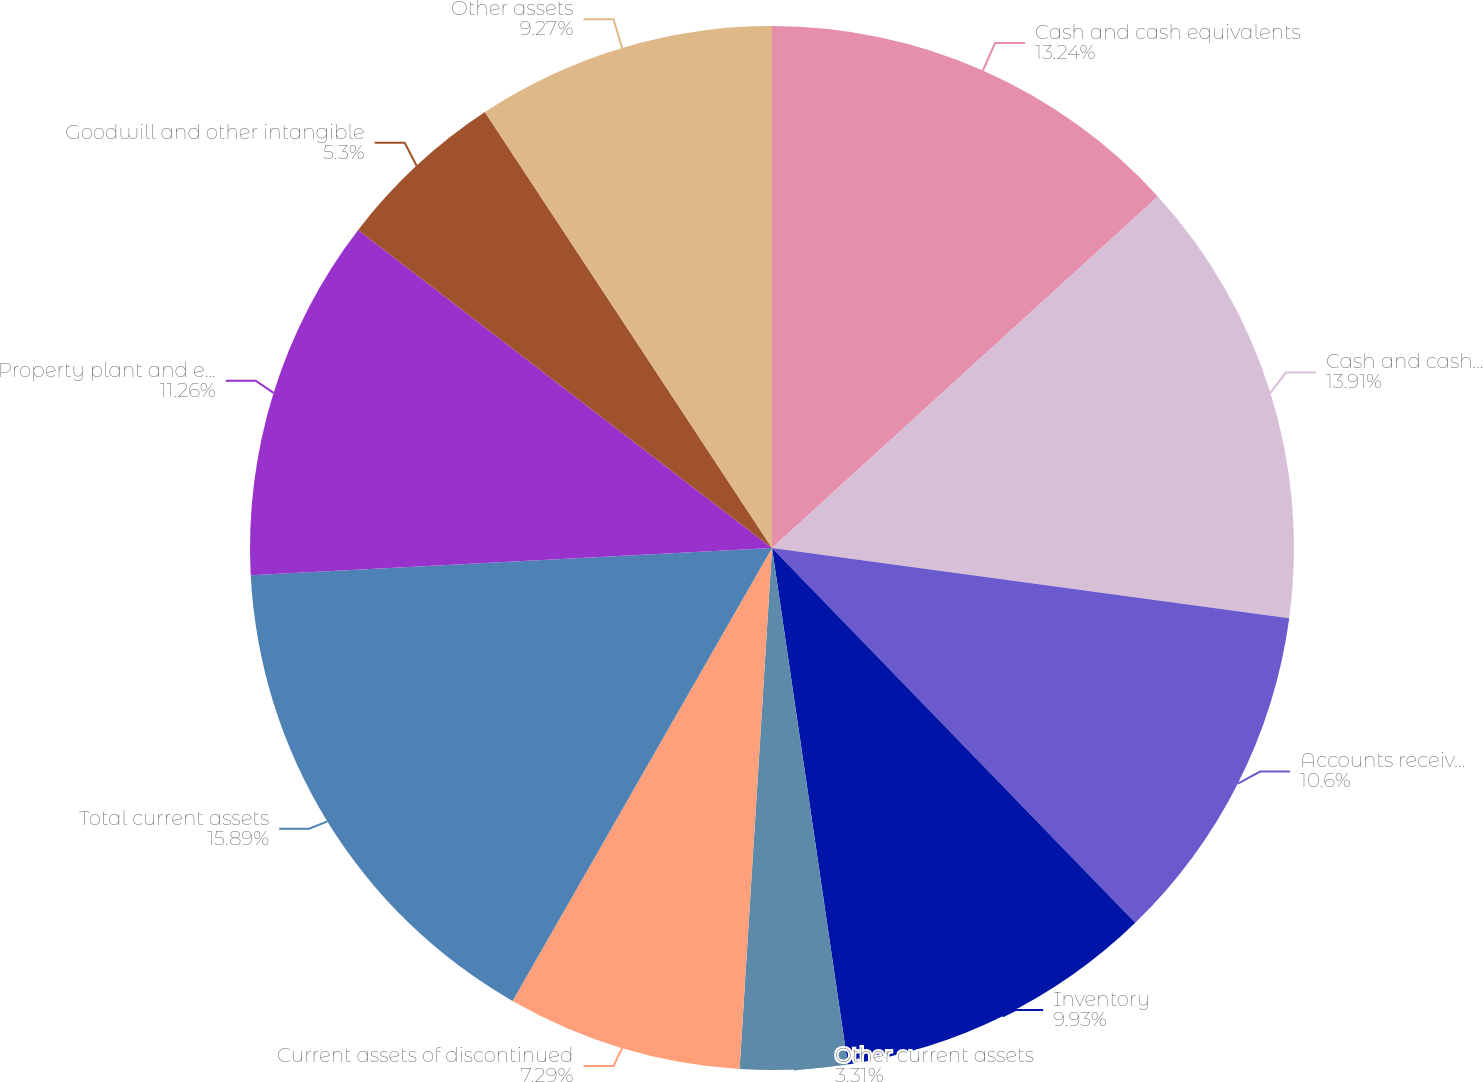<chart> <loc_0><loc_0><loc_500><loc_500><pie_chart><fcel>Cash and cash equivalents<fcel>Cash and cash equivalents and<fcel>Accounts receivable net<fcel>Inventory<fcel>Other current assets<fcel>Current assets of discontinued<fcel>Total current assets<fcel>Property plant and equipment<fcel>Goodwill and other intangible<fcel>Other assets<nl><fcel>13.24%<fcel>13.91%<fcel>10.6%<fcel>9.93%<fcel>3.31%<fcel>7.29%<fcel>15.89%<fcel>11.26%<fcel>5.3%<fcel>9.27%<nl></chart> 